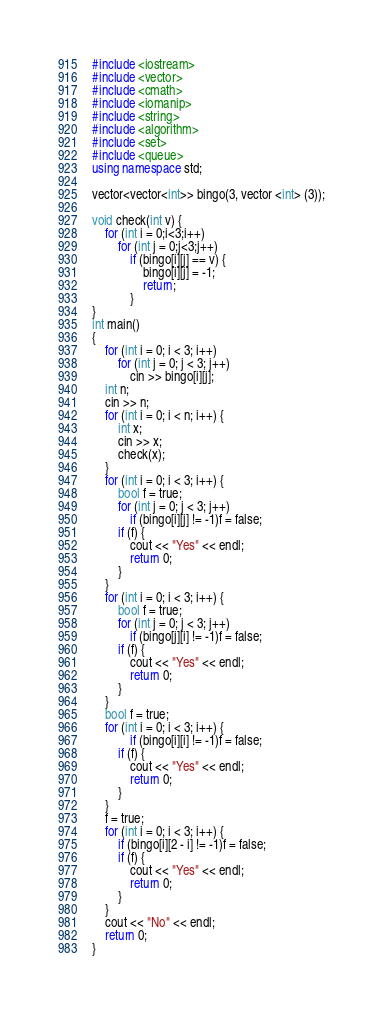Convert code to text. <code><loc_0><loc_0><loc_500><loc_500><_C++_>#include <iostream>
#include <vector>
#include <cmath>
#include <iomanip>
#include <string>
#include <algorithm>
#include <set>
#include <queue>
using namespace std;

vector<vector<int>> bingo(3, vector <int> (3));

void check(int v) {
	for (int i = 0;i<3;i++)
		for (int j = 0;j<3;j++)
			if (bingo[i][j] == v) {
				bingo[i][j] = -1;
				return;
			}
}
int main()
{
	for (int i = 0; i < 3; i++)
		for (int j = 0; j < 3; j++)
			cin >> bingo[i][j];
	int n;
	cin >> n;
	for (int i = 0; i < n; i++) {
		int x;
		cin >> x;
		check(x);
	}
	for (int i = 0; i < 3; i++) {
		bool f = true;
		for (int j = 0; j < 3; j++)
			if (bingo[i][j] != -1)f = false;
		if (f) {
			cout << "Yes" << endl;
			return 0;
		}
	}
	for (int i = 0; i < 3; i++) {
		bool f = true;
		for (int j = 0; j < 3; j++)
			if (bingo[j][i] != -1)f = false;
		if (f) {
			cout << "Yes" << endl;
			return 0;
		}
	}
	bool f = true;
	for (int i = 0; i < 3; i++) {
			if (bingo[i][i] != -1)f = false;
		if (f) {
			cout << "Yes" << endl;
			return 0;
		}
	}
	f = true;
	for (int i = 0; i < 3; i++) {
		if (bingo[i][2 - i] != -1)f = false;
		if (f) {
			cout << "Yes" << endl;
			return 0;
		}
	}
	cout << "No" << endl;
	return 0;
}

</code> 